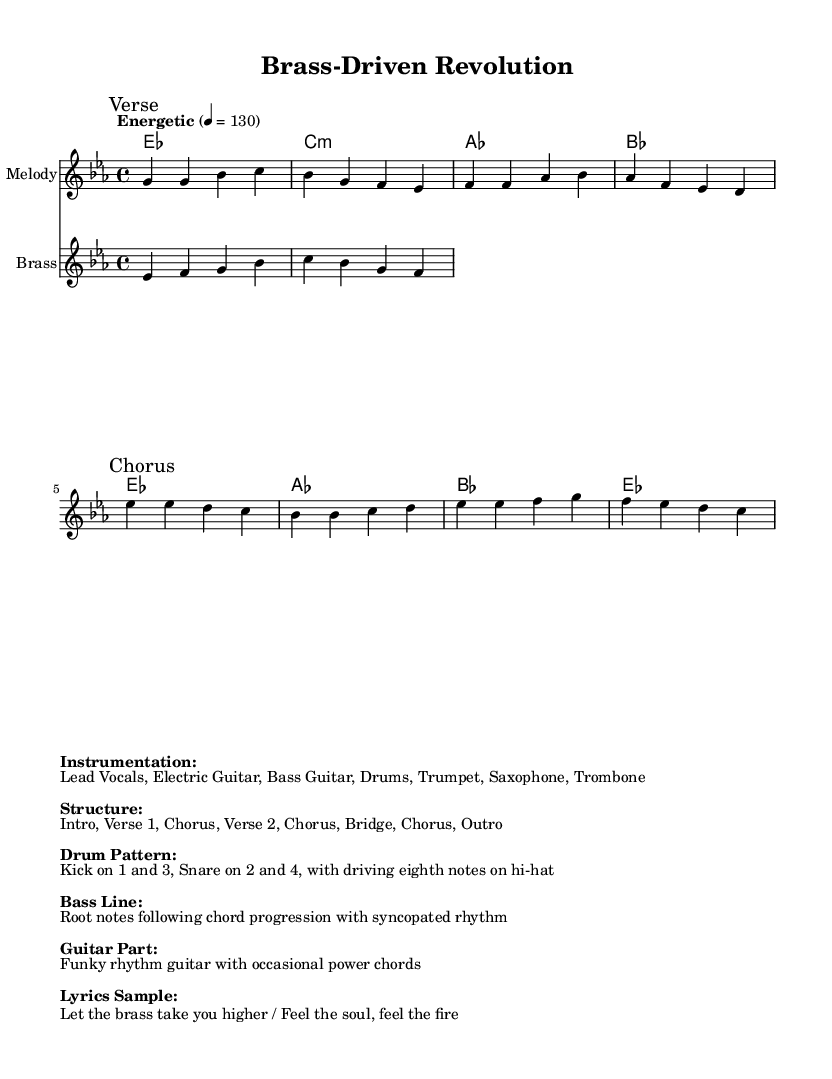What is the key signature of this music? The key signature is Es major, which has three flats: B flat, E flat, and A flat. This can be inferred from the key signature indicated at the beginning of the score.
Answer: Es major What is the time signature of this piece? The time signature is 4/4, which means there are four beats in each measure and the quarter note gets one beat. This is stated at the beginning of the score next to the key signature.
Answer: 4/4 What is the tempo marking indicated for this music? The tempo marking is "Energetic" with a metronome marking of 130 beats per minute. This suggests a lively and fast-paced feel to the music.
Answer: Energetic 4 = 130 What is the structure of this piece? The structure includes an Intro, Verse 1, Chorus, Verse 2, Chorus, Bridge, Chorus, and Outro. This is listed in the provided information as the song's layout.
Answer: Intro, Verse 1, Chorus, Verse 2, Chorus, Bridge, Chorus, Outro How many instruments are indicated for this song? The song indicates five instruments: Lead Vocals, Electric Guitar, Bass Guitar, Drums, Trumpet, Saxophone, and Trombone, as detailed in the instrumentation section. Counting these gives us a total of seven instruments.
Answer: Seven instruments What is unique about the drum pattern in this piece? The drum pattern features kicks on beats 1 and 3, snares on beats 2 and 4, along with driving eighth notes on the hi-hat. This creates a typical driving rhythm associated with energetic soul-rock.
Answer: Kicks on 1 and 3, snare on 2 and 4 What type of rhythm does the bass line follow? The bass line follows a root note pattern adhering to the chord progression, complemented by a syncopated rhythm, which adds to the groovy feel typical of soul music.
Answer: Root notes with syncopated rhythm 